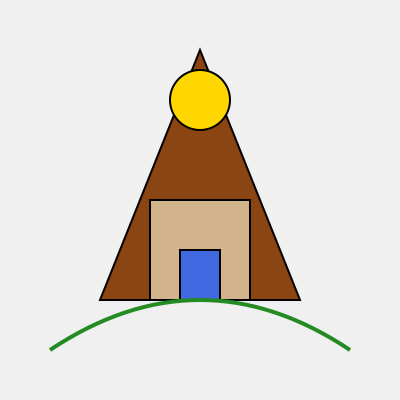Which famous local landmark is represented by this stylized drawing? To identify the landmark, let's analyze the key elements in the stylized drawing:

1. Triangular shape: The overall structure is a large triangle, which is often used to represent mountains or pyramids.
2. Brown color: The main triangular shape is colored brown, suggesting a natural formation rather than a man-made structure.
3. Rectangular base: There's a rectangular structure at the base, which could represent a building or visitor center.
4. Blue rectangle: Within the base, there's a blue rectangle that might symbolize an entrance or window.
5. Yellow circle: Near the top of the triangle, there's a yellow circle, which could represent the sun or a bright spot.
6. Green curved line: At the bottom of the image, there's a green curved line, likely representing vegetation or a river.

Considering these elements together, this stylized drawing most likely represents a famous mountain. The combination of a prominent mountain with a visitor center at its base and nearby vegetation or water is characteristic of many national parks or natural landmarks.

In many countries, such as the United States, Canada, or New Zealand, there are iconic mountains that are major tourist attractions and symbols of the local landscape. Examples include Mount Fuji in Japan, Table Mountain in South Africa, or Mount Rainier in the United States.

For immigrants learning about local landmarks, this type of stylized representation would be used to help them recognize and remember significant natural features that are important to the local culture and geography.
Answer: Mountain landmark 